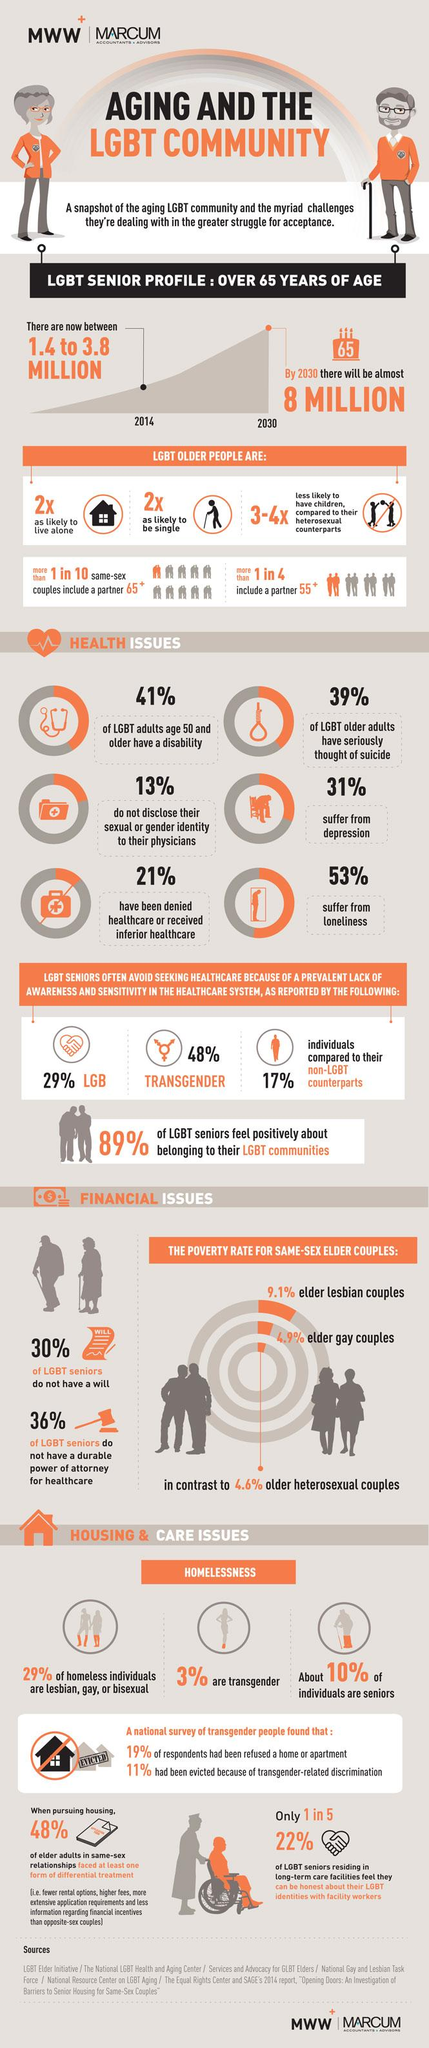Identify some key points in this picture. According to a study, 53% of individuals suffer from loneliness. According to a recent survey, only 70% of LGBT seniors have a will. It is estimated that 31% of individuals suffer from depression. The poverty rate among elder lesbian couples is significantly higher than that of older heterosexual couples, at 4.5 times the rate. By 2030, it is projected that the LGBT senior population will be approximately 8 million. 